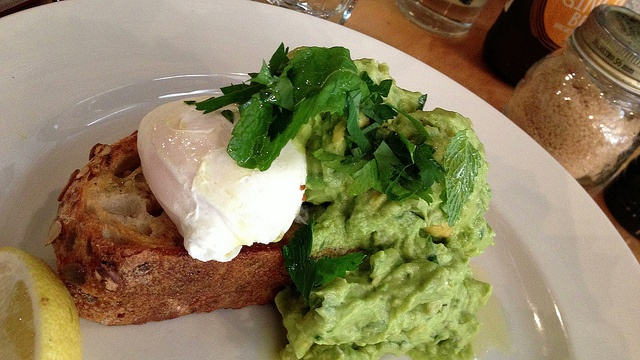Describe the objects in this image and their specific colors. I can see dining table in darkgray, black, and olive tones, bottle in black, maroon, gray, and tan tones, bottle in black, brown, maroon, and gray tones, cup in black, maroon, and gray tones, and cup in black, gray, olive, and darkgray tones in this image. 